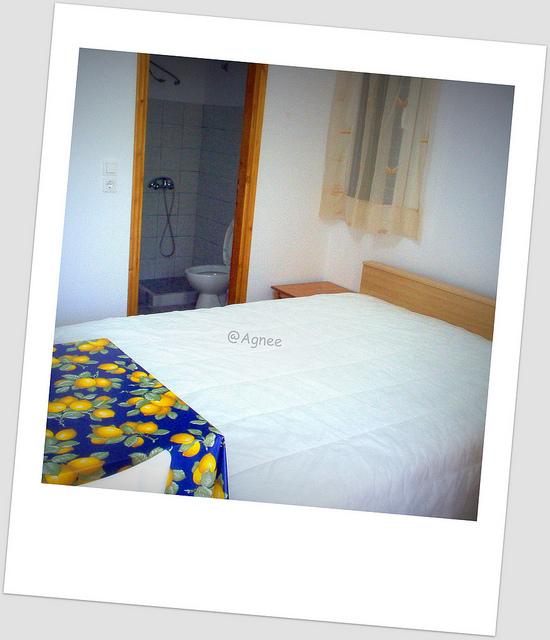What kind of room is this?
Write a very short answer. Bedroom. Is the toilet seat up?
Answer briefly. Yes. What colors stand out?
Be succinct. Blue. 